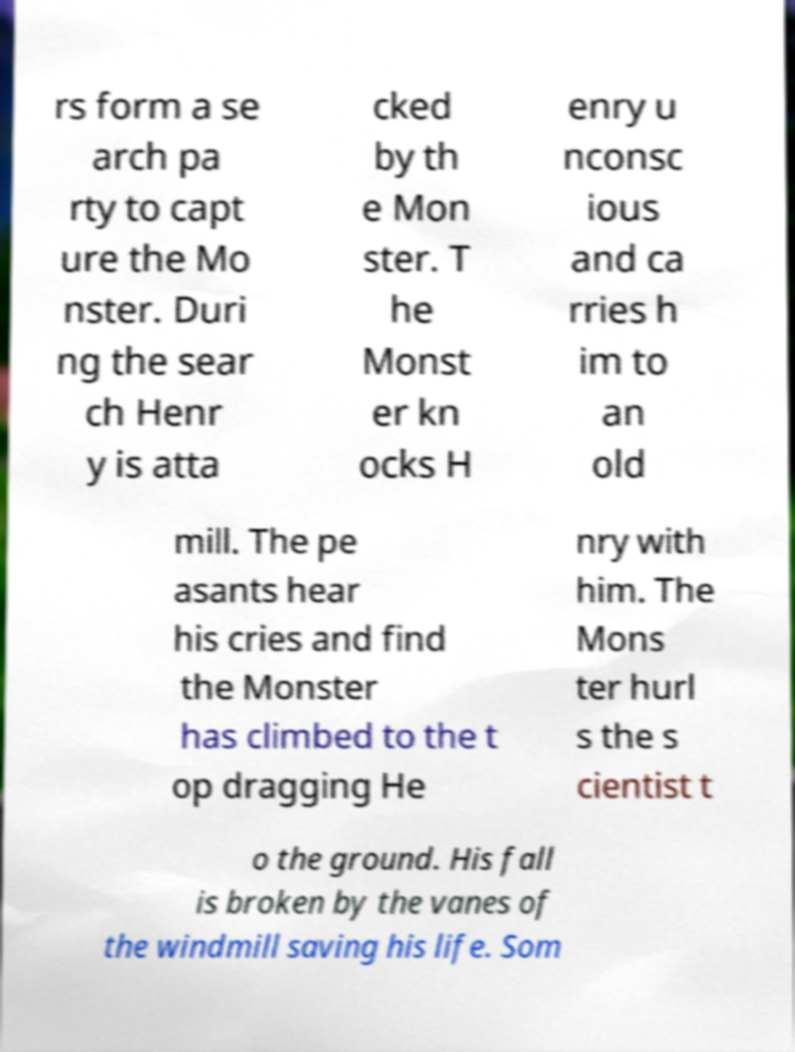Can you accurately transcribe the text from the provided image for me? rs form a se arch pa rty to capt ure the Mo nster. Duri ng the sear ch Henr y is atta cked by th e Mon ster. T he Monst er kn ocks H enry u nconsc ious and ca rries h im to an old mill. The pe asants hear his cries and find the Monster has climbed to the t op dragging He nry with him. The Mons ter hurl s the s cientist t o the ground. His fall is broken by the vanes of the windmill saving his life. Som 